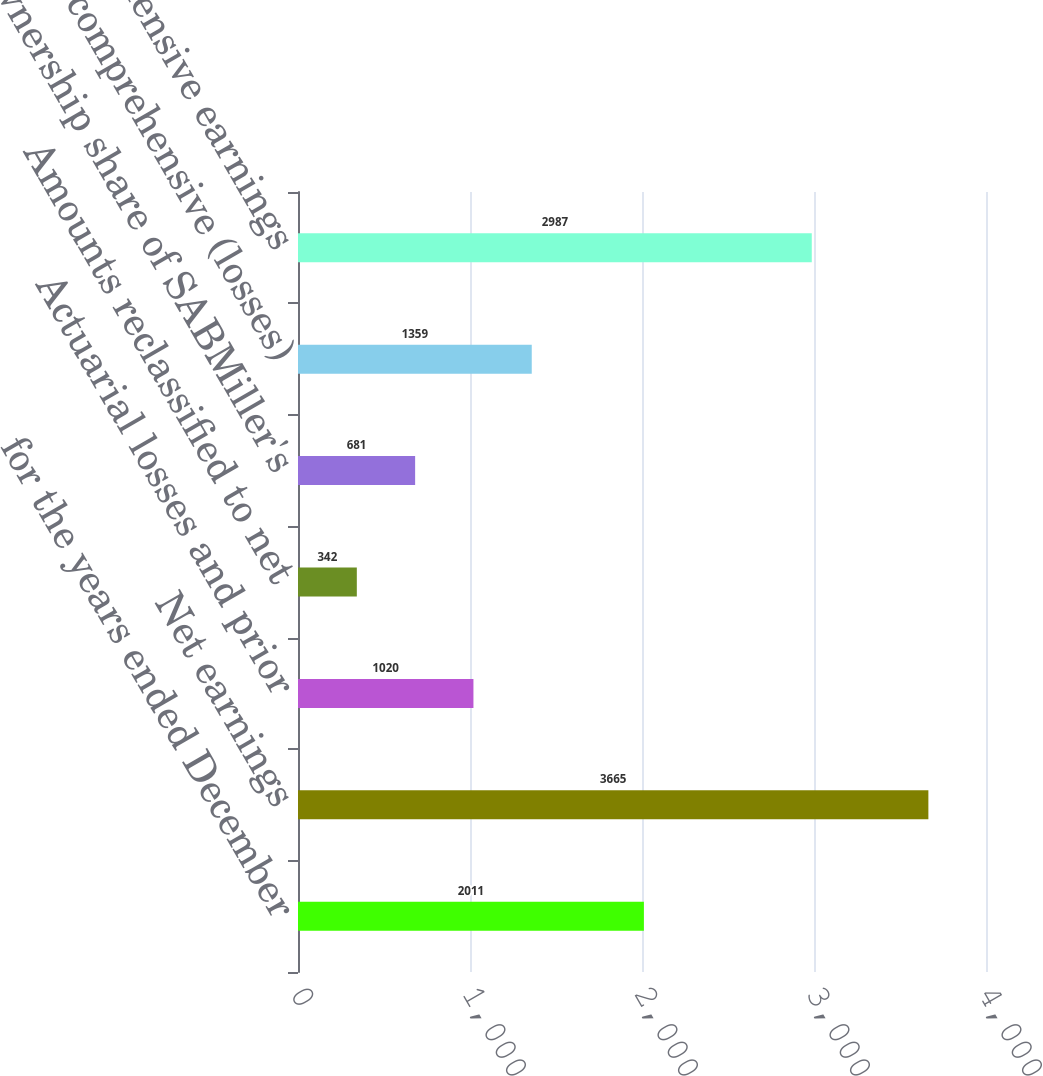Convert chart. <chart><loc_0><loc_0><loc_500><loc_500><bar_chart><fcel>for the years ended December<fcel>Net earnings<fcel>Actuarial losses and prior<fcel>Amounts reclassified to net<fcel>Ownership share of SABMiller's<fcel>Other comprehensive (losses)<fcel>Comprehensive earnings<nl><fcel>2011<fcel>3665<fcel>1020<fcel>342<fcel>681<fcel>1359<fcel>2987<nl></chart> 